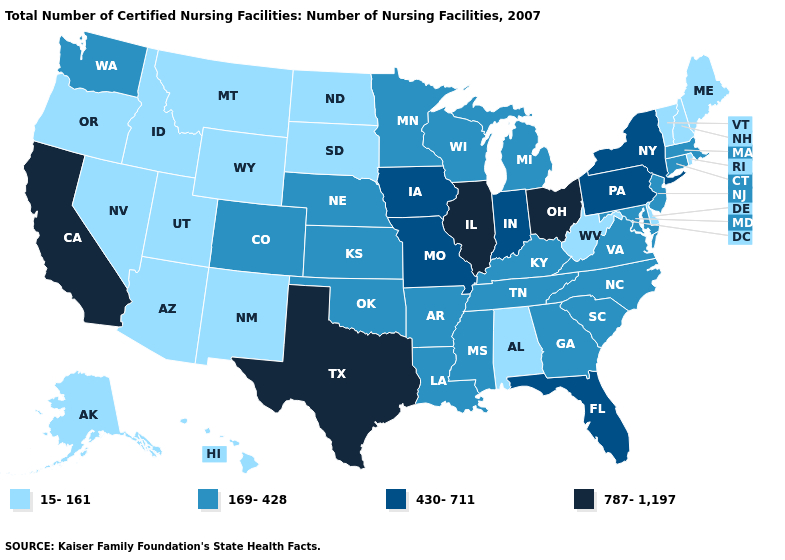Which states have the lowest value in the USA?
Write a very short answer. Alabama, Alaska, Arizona, Delaware, Hawaii, Idaho, Maine, Montana, Nevada, New Hampshire, New Mexico, North Dakota, Oregon, Rhode Island, South Dakota, Utah, Vermont, West Virginia, Wyoming. What is the highest value in the MidWest ?
Write a very short answer. 787-1,197. Name the states that have a value in the range 787-1,197?
Give a very brief answer. California, Illinois, Ohio, Texas. What is the value of Indiana?
Give a very brief answer. 430-711. What is the highest value in the USA?
Short answer required. 787-1,197. Does the map have missing data?
Short answer required. No. Does Connecticut have the lowest value in the Northeast?
Short answer required. No. Does New York have a lower value than Illinois?
Concise answer only. Yes. Name the states that have a value in the range 169-428?
Keep it brief. Arkansas, Colorado, Connecticut, Georgia, Kansas, Kentucky, Louisiana, Maryland, Massachusetts, Michigan, Minnesota, Mississippi, Nebraska, New Jersey, North Carolina, Oklahoma, South Carolina, Tennessee, Virginia, Washington, Wisconsin. Name the states that have a value in the range 430-711?
Keep it brief. Florida, Indiana, Iowa, Missouri, New York, Pennsylvania. What is the highest value in states that border Delaware?
Short answer required. 430-711. Among the states that border Wyoming , which have the highest value?
Answer briefly. Colorado, Nebraska. Which states have the lowest value in the South?
Be succinct. Alabama, Delaware, West Virginia. Does New York have the same value as North Carolina?
Concise answer only. No. Is the legend a continuous bar?
Write a very short answer. No. 